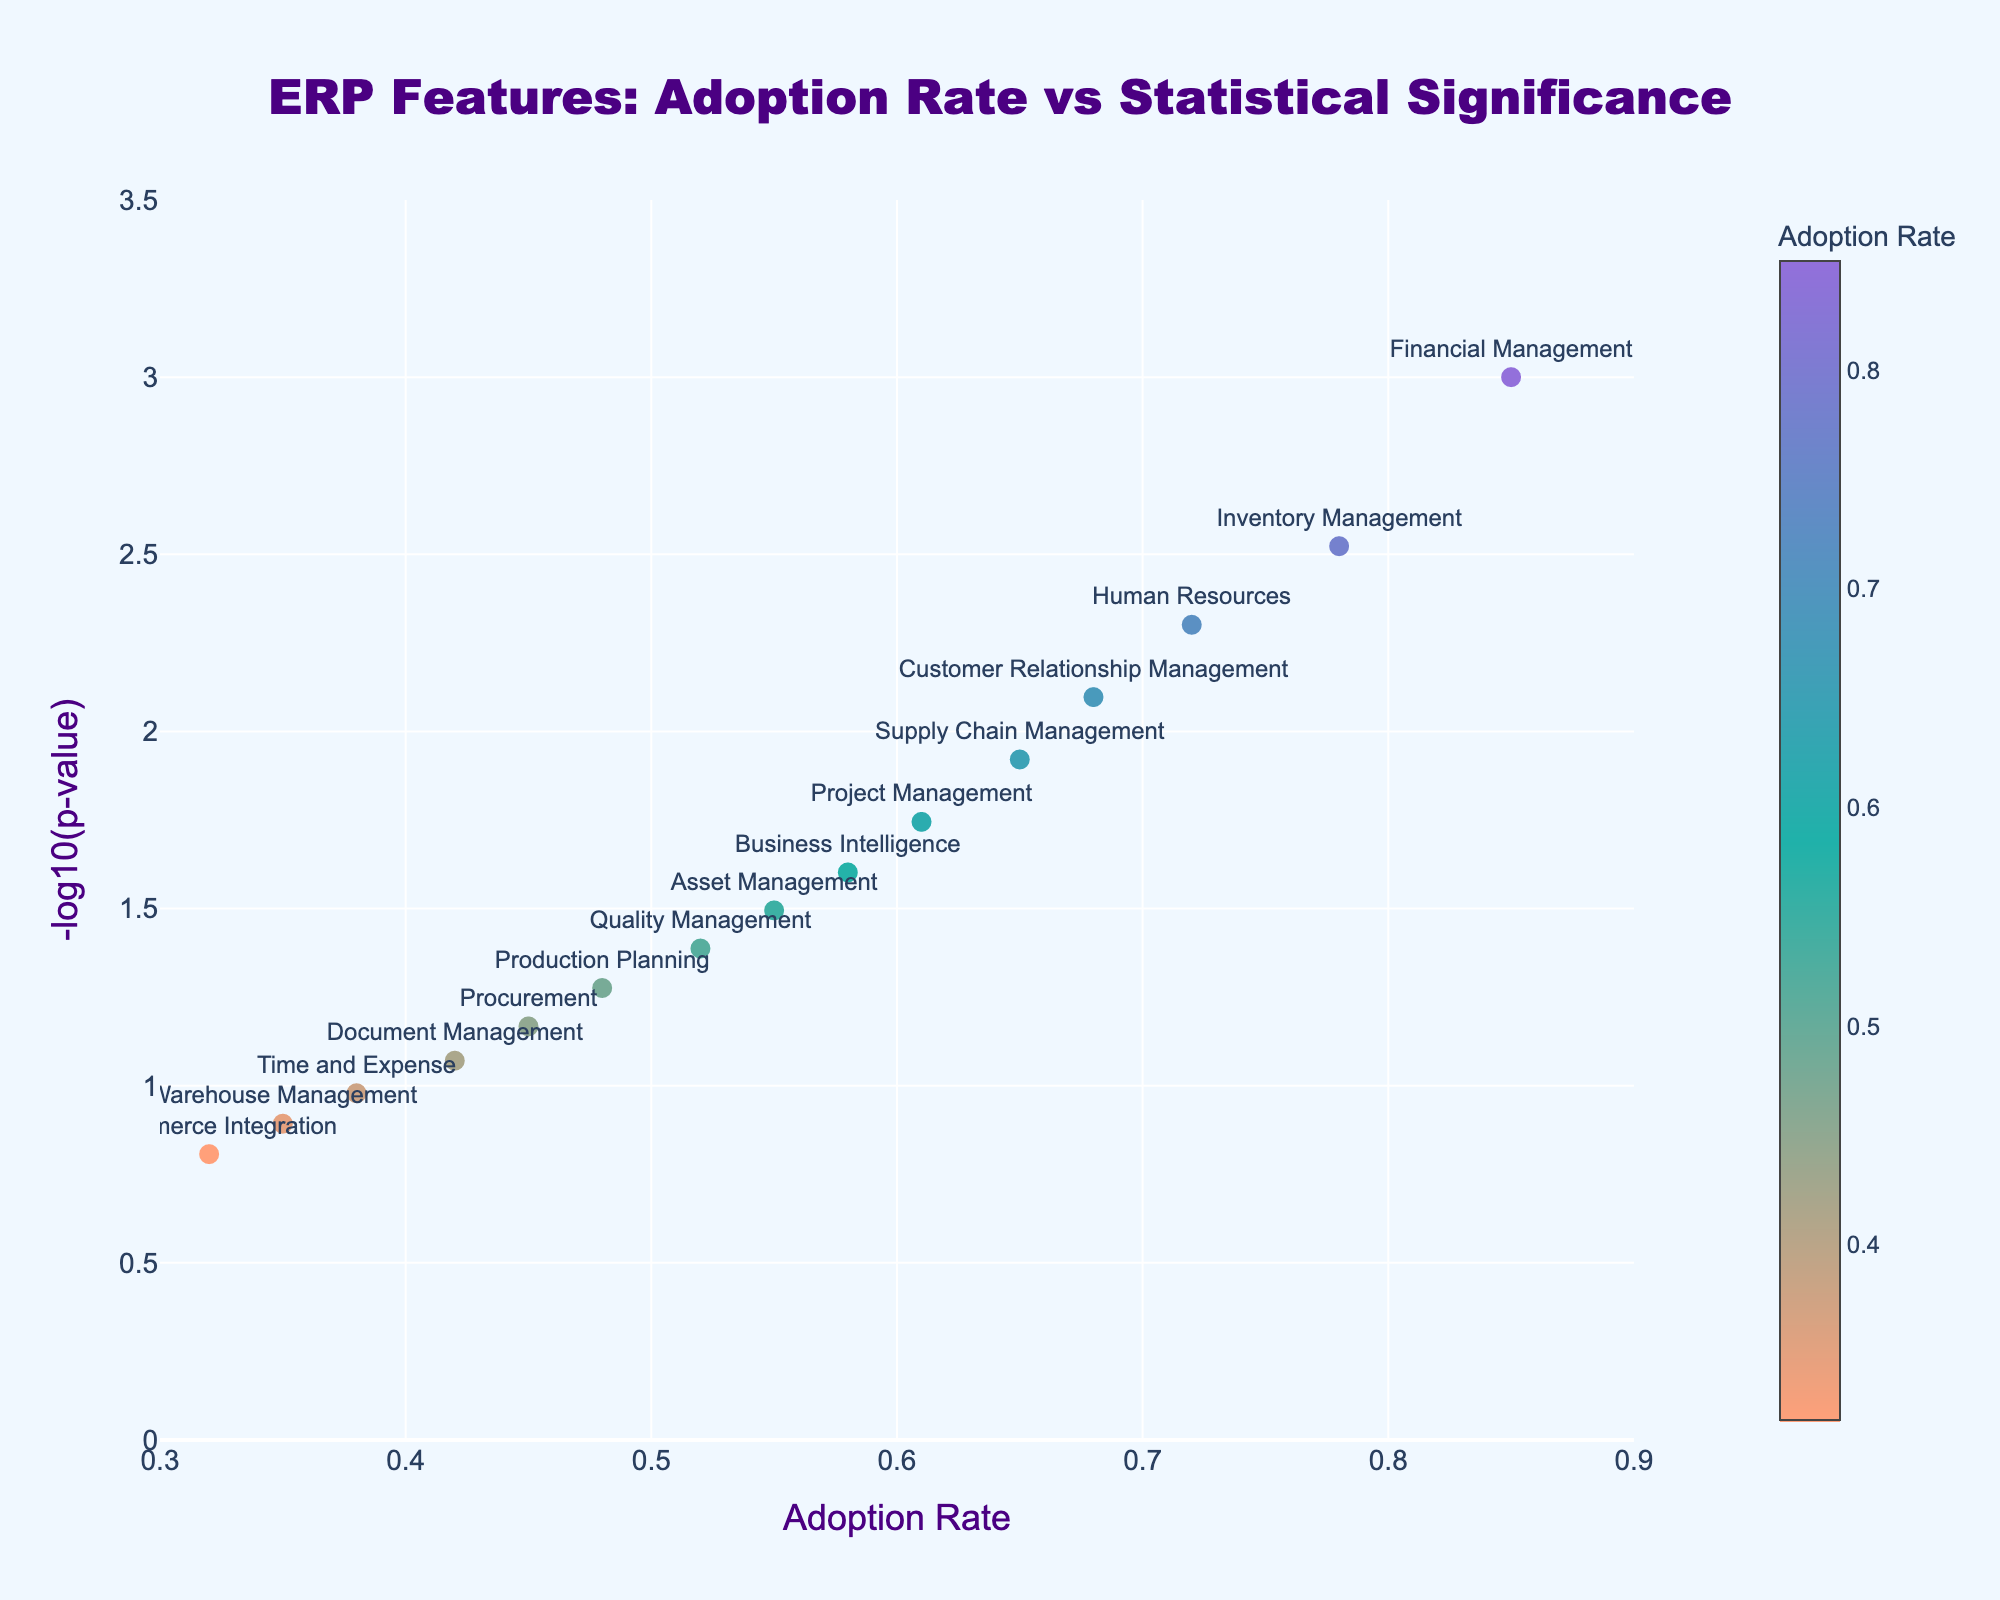Which ERP feature has the highest adoption rate? The highest adoption rate is shown on the x-axis where it reaches its maximum value. The feature with the highest adoption rate is positioned furthest to the right.
Answer: Financial Management What is the p-value for the Inventory Management feature? To find the p-value, look at the hover text for Inventory Management. The p-value is directly mentioned there.
Answer: 0.003 Which feature is less statistically significant: Quality Management or Business Intelligence? Statistical significance is represented by the y-axis value (-log10(p-value)). We compare the -log10(p-value) of Quality Management and Business Intelligence. Quality Management has a higher p-value and lower -log10(p-value), making it less significant.
Answer: Quality Management What is the title of the plot? The title of the plot is displayed at the top center of the figure.
Answer: ERP Features: Adoption Rate vs Statistical Significance How many features have an adoption rate greater than 0.6? Count the number of features with x-axis (Adoption Rate) values greater than 0.6. The features are:
- Financial Management
- Inventory Management
- Human Resources
- Customer Relationship Management
- Supply Chain Management
- Project Management.
So, there are 6 features.
Answer: 6 Compare the adoption rate of Asset Management and Time and Expense. Which one is higher? Locate the positions of Asset Management and Time and Expense on the x-axis. Asset Management has an adoption rate of 0.55, while Time and Expense has an adoption rate of 0.38. Asset Management has the higher adoption rate.
Answer: Asset Management Which feature has the smallest p-value? The feature with the smallest p-value will have the highest y-axis value (-log10(p-value)). This feature is at the top of the plot.
Answer: Financial Management What is the range of the x-axis (Adoption Rate)? The x-axis range can be found by looking at the minimum and maximum values of the Adoption Rate from the tick marks on the x-axis.
Answer: 0.3 to 0.9 Calculate the difference in the -log10(p-value) between Supply Chain Management and Document Management. Find the -log10(p-value) for both features by looking at their positions on the y-axis:
- Supply Chain Management has a -log10(p-value) of about 1.92.
- Document Management has a -log10(p-value) of about 1.07.
The difference is approximately 1.92 - 1.07 = 0.85.
Answer: 0.85 How does the color of markers change with the adoption rate? The color of the markers changes as the adoption rate goes from lower to higher. Lower adoption rates are indicated by one color, which gradually changes to another color as the adoption rate increases.
Answer: Gradually shifts 